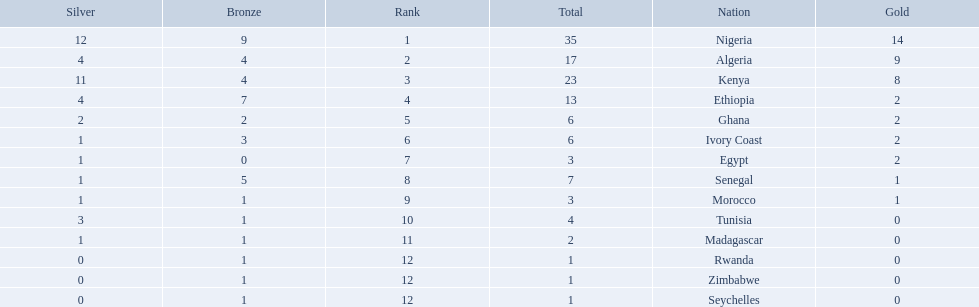What are all the nations? Nigeria, Algeria, Kenya, Ethiopia, Ghana, Ivory Coast, Egypt, Senegal, Morocco, Tunisia, Madagascar, Rwanda, Zimbabwe, Seychelles. How many bronze medals did they win? 9, 4, 4, 7, 2, 3, 0, 5, 1, 1, 1, 1, 1, 1. And which nation did not win one? Egypt. 